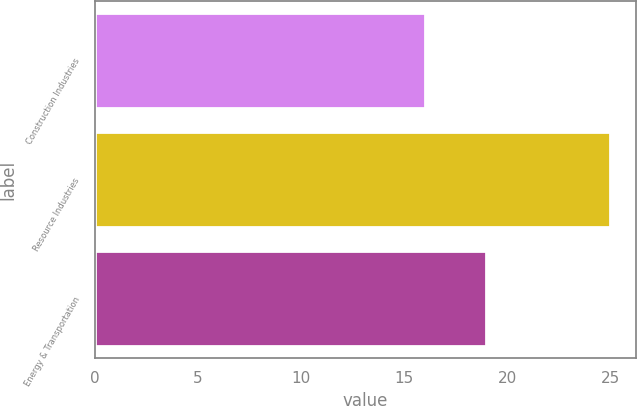<chart> <loc_0><loc_0><loc_500><loc_500><bar_chart><fcel>Construction Industries<fcel>Resource Industries<fcel>Energy & Transportation<nl><fcel>16<fcel>25<fcel>19<nl></chart> 